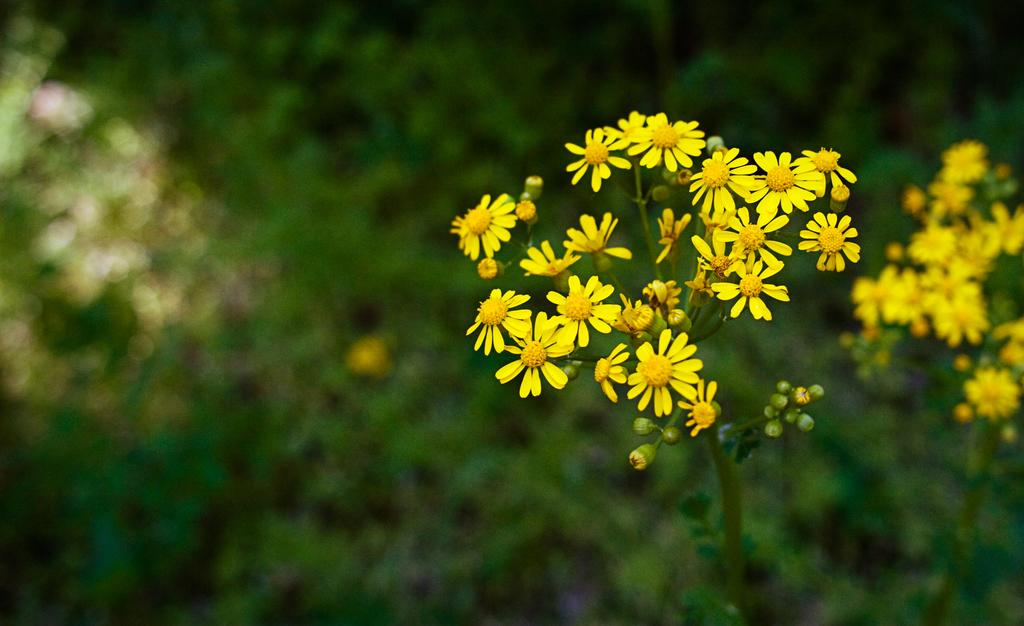What type of plants can be seen in the image? There are plants with flowers in the image. Can you describe the background of the image? The background of the image is blurred. What type of flesh can be seen on the cat in the lunchroom in the image? There is no cat or lunchroom present in the image; it only features plants with flowers and a blurred background. 